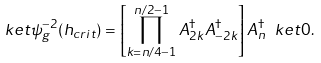Convert formula to latex. <formula><loc_0><loc_0><loc_500><loc_500>\ k e t { \psi _ { g } ^ { - 2 } ( h _ { c r i t } ) } = \left [ \prod _ { k = n / 4 - 1 } ^ { n / 2 - 1 } A _ { 2 k } ^ { \dagger } A _ { - 2 k } ^ { \dagger } \right ] A _ { n } ^ { \dagger } \ k e t { 0 } . \,</formula> 